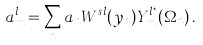<formula> <loc_0><loc_0><loc_500><loc_500>a ^ { l } _ { m } = \sum _ { n } a _ { n } W ^ { s l } ( y _ { n } ) Y ^ { l ^ { * } } _ { m } ( \Omega _ { n } ) \, .</formula> 